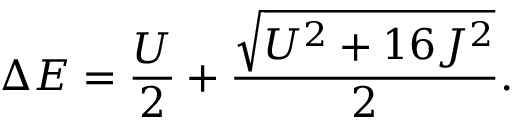<formula> <loc_0><loc_0><loc_500><loc_500>\Delta E = \frac { U } { 2 } + \frac { \sqrt { U ^ { 2 } + 1 6 J ^ { 2 } } } { 2 } .</formula> 